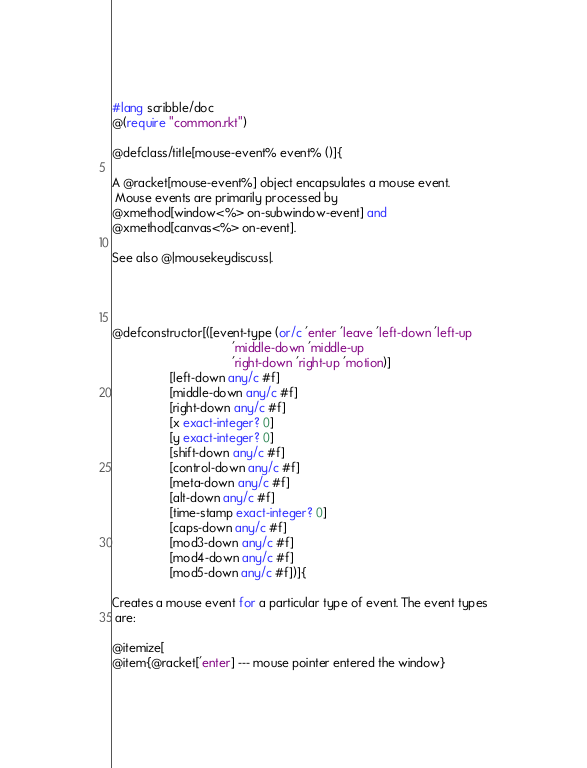<code> <loc_0><loc_0><loc_500><loc_500><_Racket_>#lang scribble/doc
@(require "common.rkt")

@defclass/title[mouse-event% event% ()]{

A @racket[mouse-event%] object encapsulates a mouse event.
 Mouse events are primarily processed by
@xmethod[window<%> on-subwindow-event] and
@xmethod[canvas<%> on-event].

See also @|mousekeydiscuss|.




@defconstructor[([event-type (or/c 'enter 'leave 'left-down 'left-up 
                                   'middle-down 'middle-up 
                                   'right-down 'right-up 'motion)]
                 [left-down any/c #f]
                 [middle-down any/c #f]
                 [right-down any/c #f]
                 [x exact-integer? 0]
                 [y exact-integer? 0]
                 [shift-down any/c #f]
                 [control-down any/c #f]
                 [meta-down any/c #f]
                 [alt-down any/c #f]
                 [time-stamp exact-integer? 0]
                 [caps-down any/c #f]
                 [mod3-down any/c #f]
                 [mod4-down any/c #f]
                 [mod5-down any/c #f])]{

Creates a mouse event for a particular type of event. The event types
 are:

@itemize[
@item{@racket['enter] --- mouse pointer entered the window}</code> 